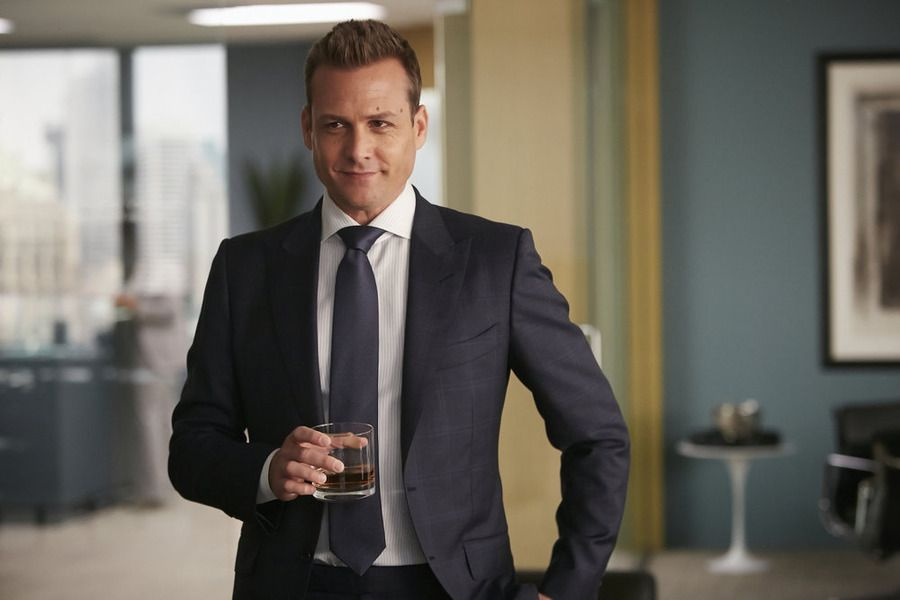Can you connect this image to a historical or cultural theme? This image evokes themes of modern capitalism and the evolution of the business elite. The man's demeanor, attire, and surroundings reflect the culmination of centuries of economic development, from the industrial revolution to the contemporary corporate world. It symbolizes the rise of the corporate executive archetype, a figure of power and refinement, representative of both personal success and the broader economic shifts that have shaped modern society. The modern office, sleek and filled with subtle art and expansive views, serves as a stage for the ongoing interplay of ambition, strategy, and the pursuit of influence within the corridors of today's economic powerhouses. In another historical context, this image could parallel the nobility of the Renaissance period. Just as Renaissance leaders donned fine attire and displayed art and luxury to signify their status, the modern business elite showcase their success through high-end fashion and refined office environments. The glass of whiskey might parallel the fine wines and spirits used historically to denote sophistication, success, and power. The large windows and cityscape resemble the grand and open courtyards of old, where wealth and power were openly displayed and venerated. In essence, the scene is a contemporary echo of the timeless human desire for status and recognition. 